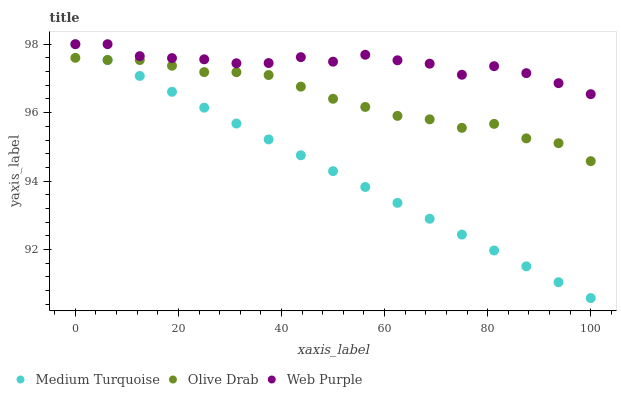Does Medium Turquoise have the minimum area under the curve?
Answer yes or no. Yes. Does Web Purple have the maximum area under the curve?
Answer yes or no. Yes. Does Olive Drab have the minimum area under the curve?
Answer yes or no. No. Does Olive Drab have the maximum area under the curve?
Answer yes or no. No. Is Medium Turquoise the smoothest?
Answer yes or no. Yes. Is Web Purple the roughest?
Answer yes or no. Yes. Is Olive Drab the smoothest?
Answer yes or no. No. Is Olive Drab the roughest?
Answer yes or no. No. Does Medium Turquoise have the lowest value?
Answer yes or no. Yes. Does Olive Drab have the lowest value?
Answer yes or no. No. Does Medium Turquoise have the highest value?
Answer yes or no. Yes. Does Olive Drab have the highest value?
Answer yes or no. No. Is Olive Drab less than Web Purple?
Answer yes or no. Yes. Is Web Purple greater than Olive Drab?
Answer yes or no. Yes. Does Medium Turquoise intersect Olive Drab?
Answer yes or no. Yes. Is Medium Turquoise less than Olive Drab?
Answer yes or no. No. Is Medium Turquoise greater than Olive Drab?
Answer yes or no. No. Does Olive Drab intersect Web Purple?
Answer yes or no. No. 